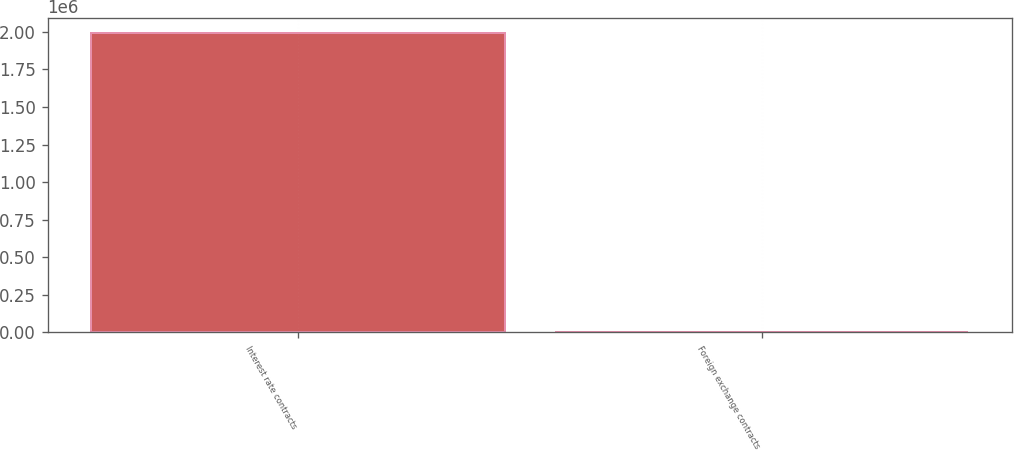<chart> <loc_0><loc_0><loc_500><loc_500><bar_chart><fcel>Interest rate contracts<fcel>Foreign exchange contracts<nl><fcel>1.99495e+06<fcel>4003<nl></chart> 